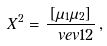<formula> <loc_0><loc_0><loc_500><loc_500>X ^ { 2 } = \frac { [ \mu _ { 1 } \mu _ { 2 } ] } { \ v e v { 1 2 } } \, ,</formula> 